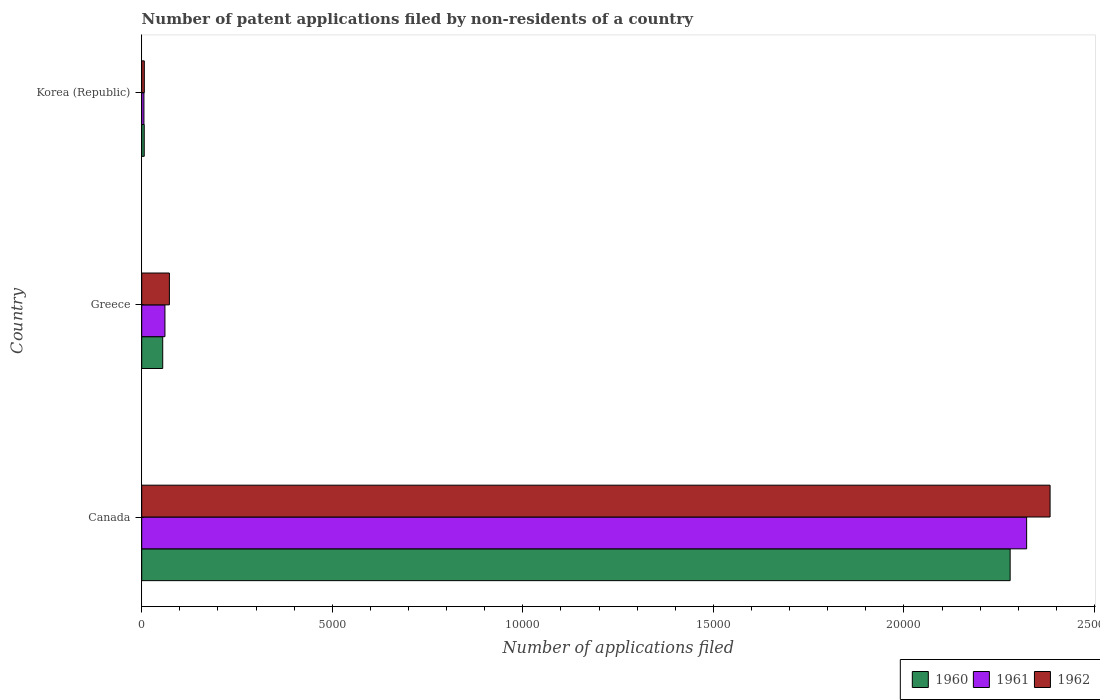How many different coloured bars are there?
Provide a succinct answer. 3. How many groups of bars are there?
Offer a very short reply. 3. Are the number of bars per tick equal to the number of legend labels?
Your answer should be compact. Yes. Are the number of bars on each tick of the Y-axis equal?
Keep it short and to the point. Yes. How many bars are there on the 1st tick from the top?
Keep it short and to the point. 3. What is the label of the 2nd group of bars from the top?
Ensure brevity in your answer.  Greece. In how many cases, is the number of bars for a given country not equal to the number of legend labels?
Give a very brief answer. 0. What is the number of applications filed in 1962 in Korea (Republic)?
Make the answer very short. 68. Across all countries, what is the maximum number of applications filed in 1962?
Give a very brief answer. 2.38e+04. In which country was the number of applications filed in 1960 minimum?
Your answer should be very brief. Korea (Republic). What is the total number of applications filed in 1961 in the graph?
Offer a terse response. 2.39e+04. What is the difference between the number of applications filed in 1961 in Greece and that in Korea (Republic)?
Keep it short and to the point. 551. What is the difference between the number of applications filed in 1962 in Canada and the number of applications filed in 1961 in Korea (Republic)?
Ensure brevity in your answer.  2.38e+04. What is the average number of applications filed in 1961 per country?
Your answer should be compact. 7962. What is the difference between the number of applications filed in 1961 and number of applications filed in 1960 in Canada?
Make the answer very short. 433. What is the ratio of the number of applications filed in 1961 in Canada to that in Korea (Republic)?
Make the answer very short. 400.33. What is the difference between the highest and the second highest number of applications filed in 1960?
Offer a very short reply. 2.22e+04. What is the difference between the highest and the lowest number of applications filed in 1962?
Provide a short and direct response. 2.38e+04. In how many countries, is the number of applications filed in 1960 greater than the average number of applications filed in 1960 taken over all countries?
Your answer should be very brief. 1. Is the sum of the number of applications filed in 1962 in Canada and Korea (Republic) greater than the maximum number of applications filed in 1960 across all countries?
Your response must be concise. Yes. What does the 1st bar from the top in Greece represents?
Your answer should be compact. 1962. What does the 1st bar from the bottom in Canada represents?
Ensure brevity in your answer.  1960. Is it the case that in every country, the sum of the number of applications filed in 1961 and number of applications filed in 1962 is greater than the number of applications filed in 1960?
Make the answer very short. Yes. How many bars are there?
Provide a short and direct response. 9. How many countries are there in the graph?
Your answer should be very brief. 3. What is the difference between two consecutive major ticks on the X-axis?
Your answer should be very brief. 5000. Does the graph contain any zero values?
Offer a very short reply. No. Does the graph contain grids?
Your answer should be compact. No. Where does the legend appear in the graph?
Provide a short and direct response. Bottom right. What is the title of the graph?
Your answer should be compact. Number of patent applications filed by non-residents of a country. What is the label or title of the X-axis?
Keep it short and to the point. Number of applications filed. What is the label or title of the Y-axis?
Your answer should be very brief. Country. What is the Number of applications filed in 1960 in Canada?
Give a very brief answer. 2.28e+04. What is the Number of applications filed in 1961 in Canada?
Your response must be concise. 2.32e+04. What is the Number of applications filed in 1962 in Canada?
Your response must be concise. 2.38e+04. What is the Number of applications filed in 1960 in Greece?
Make the answer very short. 551. What is the Number of applications filed in 1961 in Greece?
Offer a very short reply. 609. What is the Number of applications filed in 1962 in Greece?
Give a very brief answer. 726. What is the Number of applications filed of 1961 in Korea (Republic)?
Give a very brief answer. 58. What is the Number of applications filed in 1962 in Korea (Republic)?
Your response must be concise. 68. Across all countries, what is the maximum Number of applications filed in 1960?
Make the answer very short. 2.28e+04. Across all countries, what is the maximum Number of applications filed in 1961?
Your response must be concise. 2.32e+04. Across all countries, what is the maximum Number of applications filed of 1962?
Give a very brief answer. 2.38e+04. Across all countries, what is the minimum Number of applications filed in 1960?
Make the answer very short. 66. Across all countries, what is the minimum Number of applications filed of 1961?
Your answer should be compact. 58. Across all countries, what is the minimum Number of applications filed of 1962?
Provide a succinct answer. 68. What is the total Number of applications filed in 1960 in the graph?
Your response must be concise. 2.34e+04. What is the total Number of applications filed of 1961 in the graph?
Make the answer very short. 2.39e+04. What is the total Number of applications filed of 1962 in the graph?
Provide a short and direct response. 2.46e+04. What is the difference between the Number of applications filed in 1960 in Canada and that in Greece?
Offer a very short reply. 2.22e+04. What is the difference between the Number of applications filed of 1961 in Canada and that in Greece?
Offer a terse response. 2.26e+04. What is the difference between the Number of applications filed of 1962 in Canada and that in Greece?
Your response must be concise. 2.31e+04. What is the difference between the Number of applications filed of 1960 in Canada and that in Korea (Republic)?
Provide a short and direct response. 2.27e+04. What is the difference between the Number of applications filed in 1961 in Canada and that in Korea (Republic)?
Your answer should be compact. 2.32e+04. What is the difference between the Number of applications filed of 1962 in Canada and that in Korea (Republic)?
Your response must be concise. 2.38e+04. What is the difference between the Number of applications filed of 1960 in Greece and that in Korea (Republic)?
Offer a terse response. 485. What is the difference between the Number of applications filed of 1961 in Greece and that in Korea (Republic)?
Your answer should be very brief. 551. What is the difference between the Number of applications filed in 1962 in Greece and that in Korea (Republic)?
Your answer should be compact. 658. What is the difference between the Number of applications filed in 1960 in Canada and the Number of applications filed in 1961 in Greece?
Give a very brief answer. 2.22e+04. What is the difference between the Number of applications filed in 1960 in Canada and the Number of applications filed in 1962 in Greece?
Provide a short and direct response. 2.21e+04. What is the difference between the Number of applications filed in 1961 in Canada and the Number of applications filed in 1962 in Greece?
Keep it short and to the point. 2.25e+04. What is the difference between the Number of applications filed in 1960 in Canada and the Number of applications filed in 1961 in Korea (Republic)?
Keep it short and to the point. 2.27e+04. What is the difference between the Number of applications filed of 1960 in Canada and the Number of applications filed of 1962 in Korea (Republic)?
Make the answer very short. 2.27e+04. What is the difference between the Number of applications filed of 1961 in Canada and the Number of applications filed of 1962 in Korea (Republic)?
Keep it short and to the point. 2.32e+04. What is the difference between the Number of applications filed in 1960 in Greece and the Number of applications filed in 1961 in Korea (Republic)?
Make the answer very short. 493. What is the difference between the Number of applications filed of 1960 in Greece and the Number of applications filed of 1962 in Korea (Republic)?
Your answer should be very brief. 483. What is the difference between the Number of applications filed of 1961 in Greece and the Number of applications filed of 1962 in Korea (Republic)?
Your response must be concise. 541. What is the average Number of applications filed of 1960 per country?
Make the answer very short. 7801. What is the average Number of applications filed of 1961 per country?
Provide a succinct answer. 7962. What is the average Number of applications filed of 1962 per country?
Offer a terse response. 8209.33. What is the difference between the Number of applications filed in 1960 and Number of applications filed in 1961 in Canada?
Your answer should be compact. -433. What is the difference between the Number of applications filed of 1960 and Number of applications filed of 1962 in Canada?
Make the answer very short. -1048. What is the difference between the Number of applications filed of 1961 and Number of applications filed of 1962 in Canada?
Keep it short and to the point. -615. What is the difference between the Number of applications filed in 1960 and Number of applications filed in 1961 in Greece?
Your answer should be compact. -58. What is the difference between the Number of applications filed of 1960 and Number of applications filed of 1962 in Greece?
Your answer should be compact. -175. What is the difference between the Number of applications filed in 1961 and Number of applications filed in 1962 in Greece?
Provide a short and direct response. -117. What is the difference between the Number of applications filed in 1960 and Number of applications filed in 1961 in Korea (Republic)?
Provide a short and direct response. 8. What is the difference between the Number of applications filed of 1960 and Number of applications filed of 1962 in Korea (Republic)?
Provide a succinct answer. -2. What is the ratio of the Number of applications filed of 1960 in Canada to that in Greece?
Offer a terse response. 41.35. What is the ratio of the Number of applications filed in 1961 in Canada to that in Greece?
Provide a succinct answer. 38.13. What is the ratio of the Number of applications filed of 1962 in Canada to that in Greece?
Ensure brevity in your answer.  32.83. What is the ratio of the Number of applications filed in 1960 in Canada to that in Korea (Republic)?
Keep it short and to the point. 345.24. What is the ratio of the Number of applications filed in 1961 in Canada to that in Korea (Republic)?
Offer a very short reply. 400.33. What is the ratio of the Number of applications filed in 1962 in Canada to that in Korea (Republic)?
Offer a terse response. 350.5. What is the ratio of the Number of applications filed of 1960 in Greece to that in Korea (Republic)?
Your answer should be compact. 8.35. What is the ratio of the Number of applications filed in 1961 in Greece to that in Korea (Republic)?
Ensure brevity in your answer.  10.5. What is the ratio of the Number of applications filed in 1962 in Greece to that in Korea (Republic)?
Your answer should be compact. 10.68. What is the difference between the highest and the second highest Number of applications filed in 1960?
Give a very brief answer. 2.22e+04. What is the difference between the highest and the second highest Number of applications filed of 1961?
Keep it short and to the point. 2.26e+04. What is the difference between the highest and the second highest Number of applications filed in 1962?
Your answer should be very brief. 2.31e+04. What is the difference between the highest and the lowest Number of applications filed of 1960?
Your answer should be compact. 2.27e+04. What is the difference between the highest and the lowest Number of applications filed of 1961?
Ensure brevity in your answer.  2.32e+04. What is the difference between the highest and the lowest Number of applications filed of 1962?
Provide a short and direct response. 2.38e+04. 